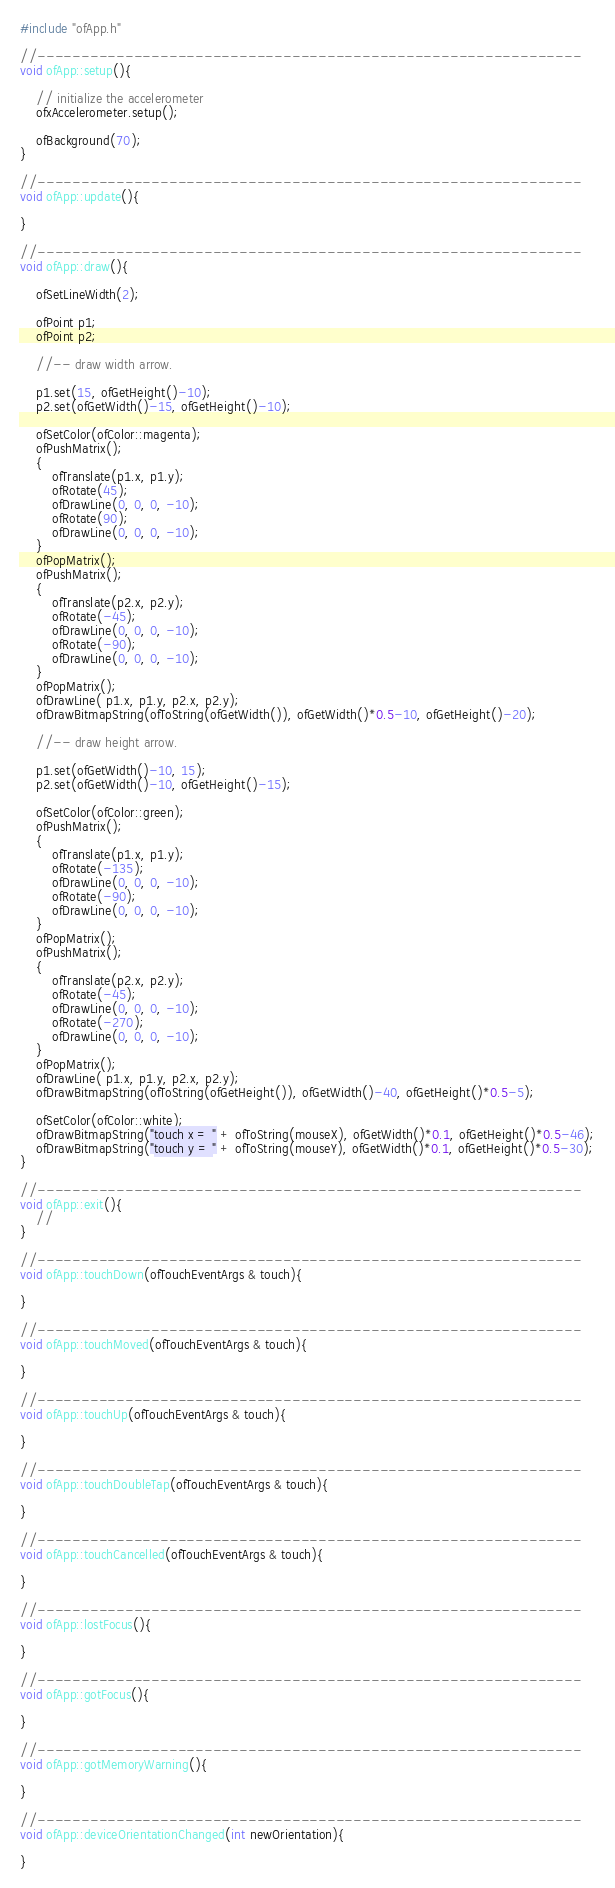Convert code to text. <code><loc_0><loc_0><loc_500><loc_500><_ObjectiveC_>#include "ofApp.h"

//--------------------------------------------------------------
void ofApp::setup(){	
	
    // initialize the accelerometer
	ofxAccelerometer.setup();
	
	ofBackground(70);
}

//--------------------------------------------------------------
void ofApp::update(){

}

//--------------------------------------------------------------
void ofApp::draw(){
    
    ofSetLineWidth(2);
    
    ofPoint p1;
    ofPoint p2;
    
    //-- draw width arrow.
    
    p1.set(15, ofGetHeight()-10);
    p2.set(ofGetWidth()-15, ofGetHeight()-10);
    
	ofSetColor(ofColor::magenta);
    ofPushMatrix();
    {
        ofTranslate(p1.x, p1.y);
        ofRotate(45);
        ofDrawLine(0, 0, 0, -10);
        ofRotate(90);
        ofDrawLine(0, 0, 0, -10);
    }
    ofPopMatrix();
    ofPushMatrix();
    {
        ofTranslate(p2.x, p2.y);
        ofRotate(-45);
        ofDrawLine(0, 0, 0, -10);
        ofRotate(-90);
        ofDrawLine(0, 0, 0, -10);
    }
    ofPopMatrix();
    ofDrawLine( p1.x, p1.y, p2.x, p2.y);
    ofDrawBitmapString(ofToString(ofGetWidth()), ofGetWidth()*0.5-10, ofGetHeight()-20);
    
    //-- draw height arrow.
    
    p1.set(ofGetWidth()-10, 15);
    p2.set(ofGetWidth()-10, ofGetHeight()-15);
    
    ofSetColor(ofColor::green);
    ofPushMatrix();
    {
        ofTranslate(p1.x, p1.y);
        ofRotate(-135);
        ofDrawLine(0, 0, 0, -10);
        ofRotate(-90);
        ofDrawLine(0, 0, 0, -10);
    }
    ofPopMatrix();
    ofPushMatrix();
    {
        ofTranslate(p2.x, p2.y);
        ofRotate(-45);
        ofDrawLine(0, 0, 0, -10);
        ofRotate(-270);
        ofDrawLine(0, 0, 0, -10);
    }
    ofPopMatrix();
    ofDrawLine( p1.x, p1.y, p2.x, p2.y);
    ofDrawBitmapString(ofToString(ofGetHeight()), ofGetWidth()-40, ofGetHeight()*0.5-5);
    
    ofSetColor(ofColor::white);
    ofDrawBitmapString("touch x = " + ofToString(mouseX), ofGetWidth()*0.1, ofGetHeight()*0.5-46);
    ofDrawBitmapString("touch y = " + ofToString(mouseY), ofGetWidth()*0.1, ofGetHeight()*0.5-30);
}

//--------------------------------------------------------------
void ofApp::exit(){
    //
}

//--------------------------------------------------------------
void ofApp::touchDown(ofTouchEventArgs & touch){

}

//--------------------------------------------------------------
void ofApp::touchMoved(ofTouchEventArgs & touch){

}

//--------------------------------------------------------------
void ofApp::touchUp(ofTouchEventArgs & touch){

}

//--------------------------------------------------------------
void ofApp::touchDoubleTap(ofTouchEventArgs & touch){

}

//--------------------------------------------------------------
void ofApp::touchCancelled(ofTouchEventArgs & touch){
    
}

//--------------------------------------------------------------
void ofApp::lostFocus(){

}

//--------------------------------------------------------------
void ofApp::gotFocus(){

}

//--------------------------------------------------------------
void ofApp::gotMemoryWarning(){

}

//--------------------------------------------------------------
void ofApp::deviceOrientationChanged(int newOrientation){

}

</code> 